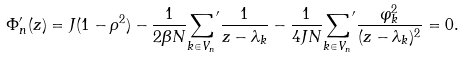Convert formula to latex. <formula><loc_0><loc_0><loc_500><loc_500>\Phi _ { n } ^ { \prime } ( z ) = J ( 1 - \rho ^ { 2 } ) - \frac { 1 } { 2 \beta N } { \sum _ { k \in V _ { n } } } ^ { \prime } \frac { 1 } { z - \lambda _ { k } } - \frac { 1 } { 4 J N } { \sum _ { k \in V _ { n } } } ^ { \prime } \frac { \varphi _ { k } ^ { 2 } } { ( z - \lambda _ { k } ) ^ { 2 } } = 0 .</formula> 